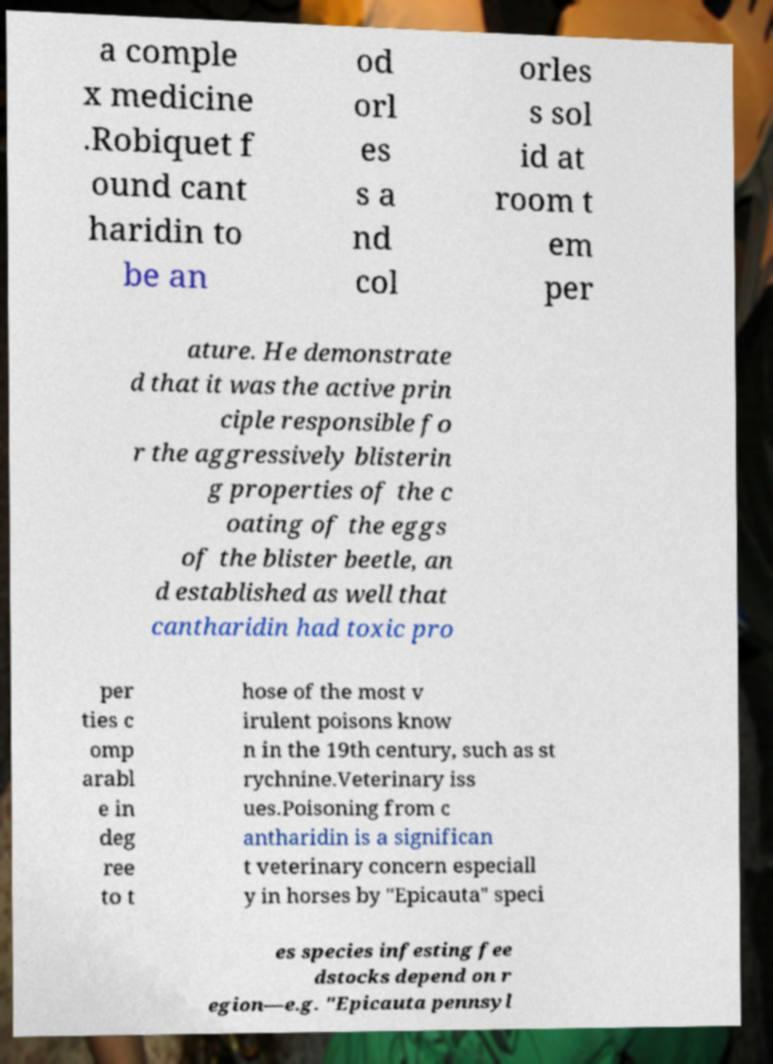For documentation purposes, I need the text within this image transcribed. Could you provide that? a comple x medicine .Robiquet f ound cant haridin to be an od orl es s a nd col orles s sol id at room t em per ature. He demonstrate d that it was the active prin ciple responsible fo r the aggressively blisterin g properties of the c oating of the eggs of the blister beetle, an d established as well that cantharidin had toxic pro per ties c omp arabl e in deg ree to t hose of the most v irulent poisons know n in the 19th century, such as st rychnine.Veterinary iss ues.Poisoning from c antharidin is a significan t veterinary concern especiall y in horses by "Epicauta" speci es species infesting fee dstocks depend on r egion—e.g. "Epicauta pennsyl 